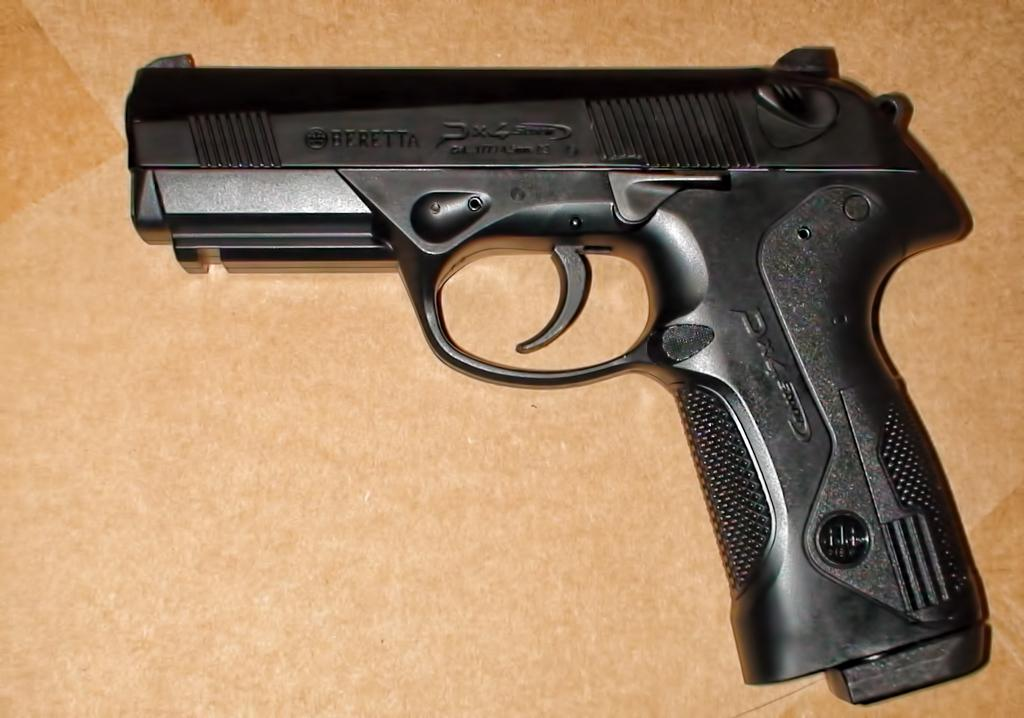What object is the main focus of the image? There is a gun in the image. Where is the gun placed? The gun is on a wooden surface. What type of teaching is being conducted on the roof in the image? There is no teaching or roof present in the image; it only features a gun on a wooden surface. 